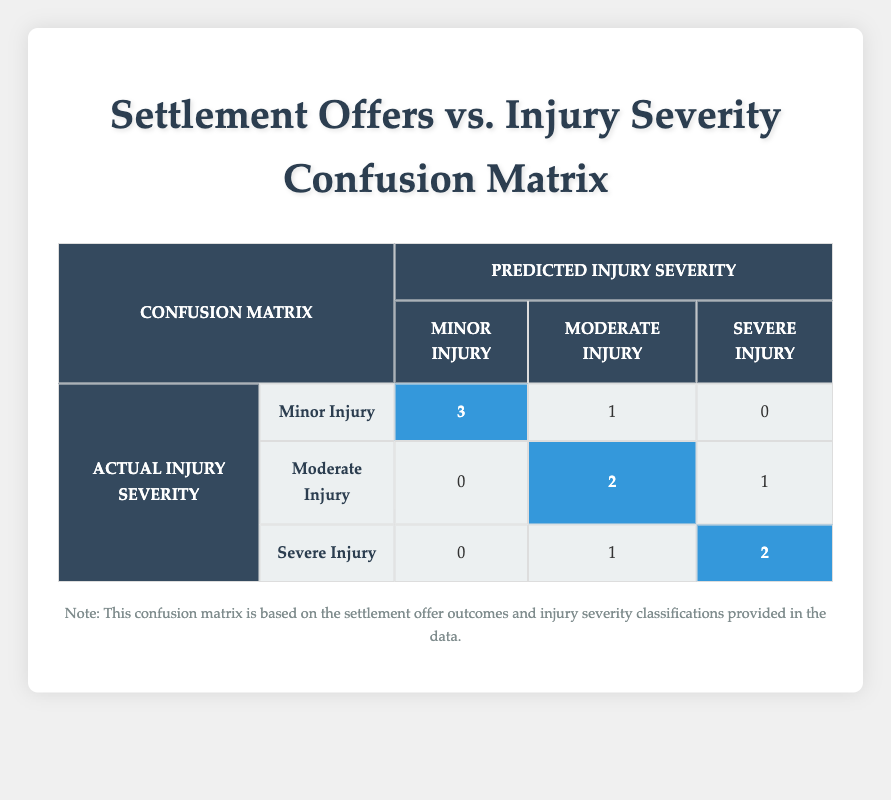What is the total number of cases with Minor Injury that were accepted? From the confusion matrix, the "Minor Injury" row shows that there are 3 accepted cases. This is the direct count from the table.
Answer: 3 How many Moderate Injury cases were rejected? The "Moderate Injury" row in the confusion matrix shows 2 rejected cases. This value is clearly stated in the corresponding cell within the table.
Answer: 2 Is it true that all Severe Injury cases had accepted settlement offers? Looking at the "Severe Injury" row, we can see that there are 1 rejected case and 2 accepted cases. Thus, it is false that all Severe Injury cases had accepted offers.
Answer: No What is the difference between the number of accepted and rejected cases for Minor Injury? For Minor Injury, there are 3 accepted and 1 rejected case. To find the difference, subtract the rejected (1) from the accepted (3): 3 - 1 = 2.
Answer: 2 How many total cases were classified as Severe Injury? In the confusion matrix under the "Severe Injury" category, there are 3 cases: 2 accepted and 1 rejected. Adding these outcomes gives a total of 2 + 1 = 3 cases classified as Severe Injury.
Answer: 3 What percentage of Moderate Injury cases were accepted? The confusion matrix shows a total of 3 Moderate Injury cases (2 accepted and 1 rejected). To find the percentage: (2 accepted / 3 total) * 100 = 66.67%.
Answer: 66.67% If you consider all the accepted settlement offers, what percentage corresponds to Minor Injury cases? There are 5 total accepted offers (3 Minor, 2 Moderate, 2 Severe) and 3 of those are Minor Injury. To find the percentage: (3 Minor / 5 total) * 100 = 60%.
Answer: 60% What injury severity classification has the highest number of accepted cases? By comparing the accepted counts across injury severity classifications, Minor Injury has 3 accepted, Moderate Injury has 2 accepted, and Severe Injury has 2 accepted. Therefore, Minor Injury has the highest count.
Answer: Minor Injury What is the average settlement offer for accepted cases across all injury severities? The accepted settlement offers are 5000, 7000, 25000, 50000, 80000. Adding these gives us 5000 + 7000 + 25000 + 50000 + 80000 = 137000. There are 5 accepted cases, so the average is 137000 / 5 = 27400.
Answer: 27400 